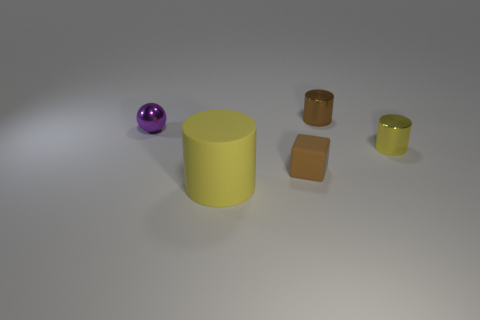Add 1 metallic objects. How many objects exist? 6 Subtract all cylinders. How many objects are left? 2 Add 1 green objects. How many green objects exist? 1 Subtract 0 red spheres. How many objects are left? 5 Subtract all yellow metal things. Subtract all tiny things. How many objects are left? 0 Add 1 matte things. How many matte things are left? 3 